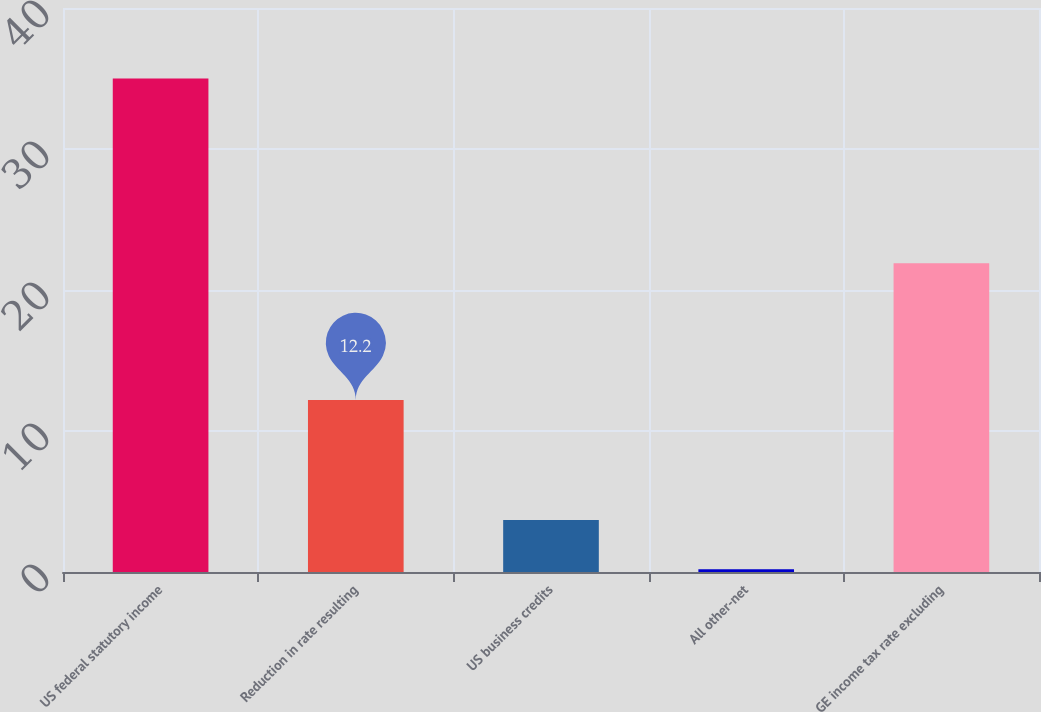Convert chart. <chart><loc_0><loc_0><loc_500><loc_500><bar_chart><fcel>US federal statutory income<fcel>Reduction in rate resulting<fcel>US business credits<fcel>All other-net<fcel>GE income tax rate excluding<nl><fcel>35<fcel>12.2<fcel>3.68<fcel>0.2<fcel>21.9<nl></chart> 